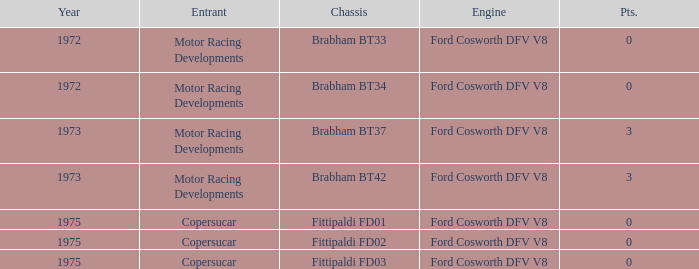Which motor from 1973 possesses a brabham bt37 chassis? Ford Cosworth DFV V8. 